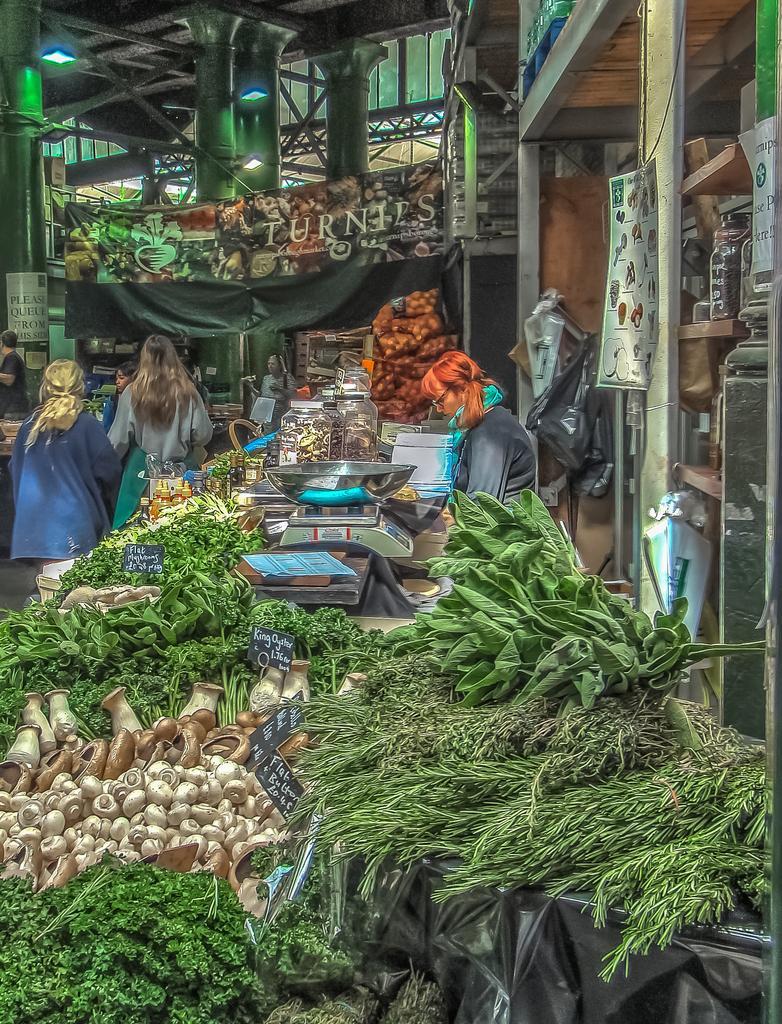How would you summarize this image in a sentence or two? In this image we can see few people. There are leafy vegetables, mushrooms and many other items. Also there are price tags and there is a black color sheet. On the right side there is a cupboard with some items. And there is a weighing machine. In the back there are pillars, rods and lights. Also there is a banner. 